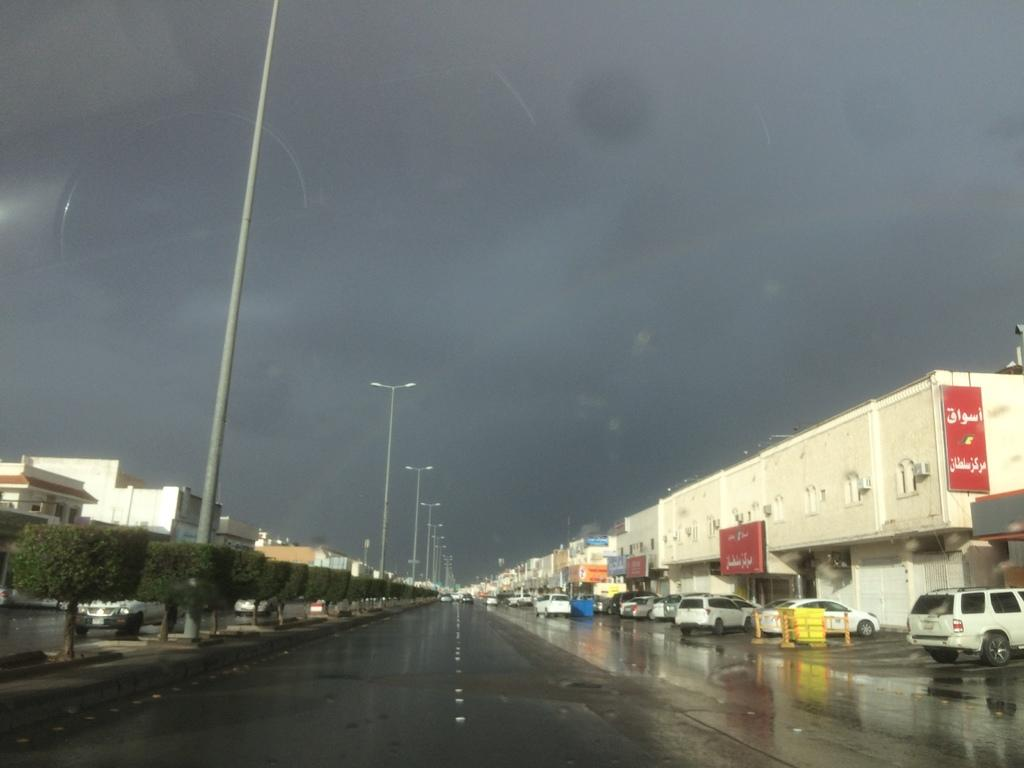What type of vehicles can be seen on the road in the image? There are cars on the road in the image. What other objects can be seen in the image besides cars? There are trees, poles, buildings, and banners in the image. What is visible in the background of the image? The sky is visible in the background of the image. Where is the drawer located in the image? There is no drawer present in the image. What type of credit is being offered on the banners in the image? There is no mention of credit or any specific offer on the banners in the image. 